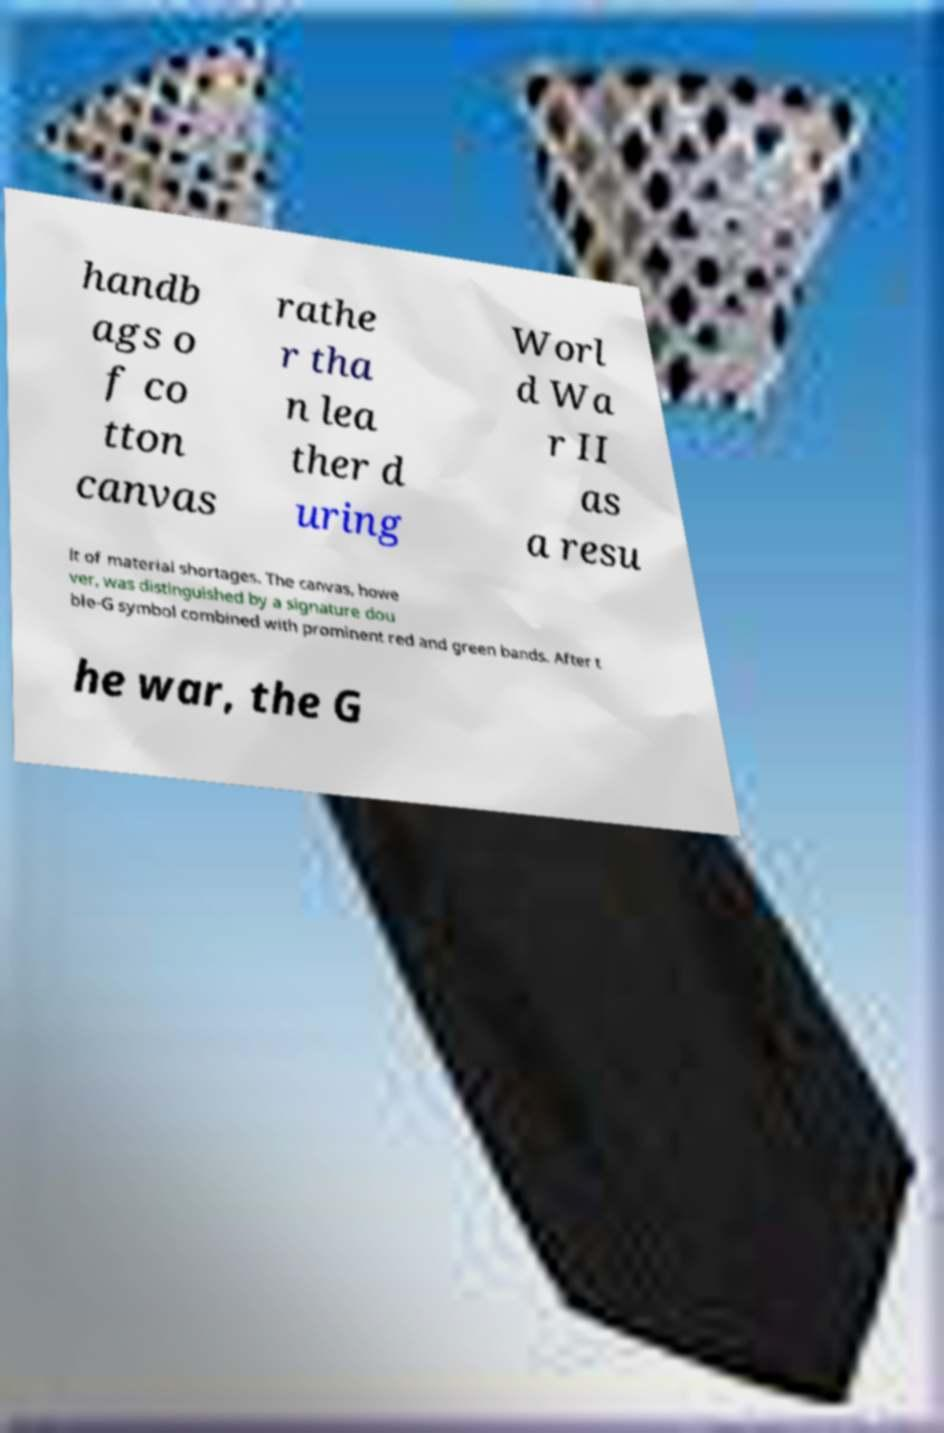Please read and relay the text visible in this image. What does it say? handb ags o f co tton canvas rathe r tha n lea ther d uring Worl d Wa r II as a resu lt of material shortages. The canvas, howe ver, was distinguished by a signature dou ble-G symbol combined with prominent red and green bands. After t he war, the G 